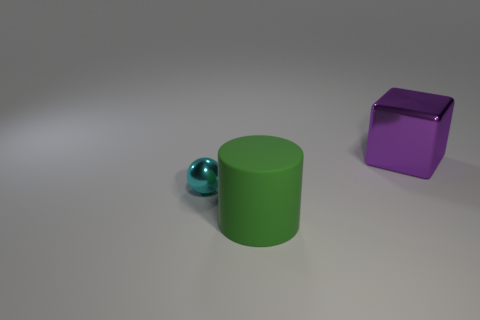What number of other green objects have the same material as the green thing? 0 